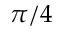<formula> <loc_0><loc_0><loc_500><loc_500>\pi / 4</formula> 